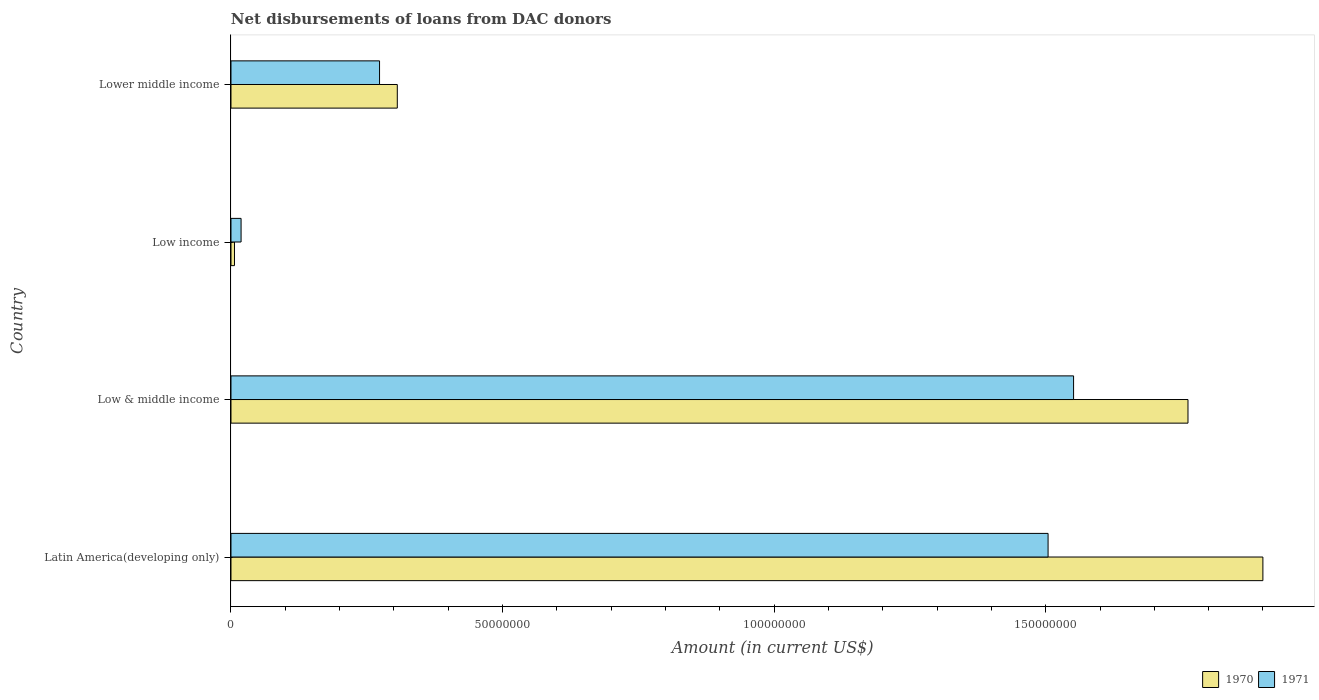How many different coloured bars are there?
Your answer should be compact. 2. Are the number of bars per tick equal to the number of legend labels?
Give a very brief answer. Yes. Are the number of bars on each tick of the Y-axis equal?
Provide a short and direct response. Yes. How many bars are there on the 4th tick from the top?
Ensure brevity in your answer.  2. How many bars are there on the 2nd tick from the bottom?
Your answer should be very brief. 2. What is the label of the 1st group of bars from the top?
Keep it short and to the point. Lower middle income. In how many cases, is the number of bars for a given country not equal to the number of legend labels?
Give a very brief answer. 0. What is the amount of loans disbursed in 1971 in Low & middle income?
Provide a short and direct response. 1.55e+08. Across all countries, what is the maximum amount of loans disbursed in 1971?
Ensure brevity in your answer.  1.55e+08. Across all countries, what is the minimum amount of loans disbursed in 1970?
Keep it short and to the point. 6.47e+05. In which country was the amount of loans disbursed in 1971 minimum?
Your answer should be compact. Low income. What is the total amount of loans disbursed in 1970 in the graph?
Offer a terse response. 3.97e+08. What is the difference between the amount of loans disbursed in 1970 in Latin America(developing only) and that in Lower middle income?
Your response must be concise. 1.59e+08. What is the difference between the amount of loans disbursed in 1971 in Low income and the amount of loans disbursed in 1970 in Latin America(developing only)?
Your response must be concise. -1.88e+08. What is the average amount of loans disbursed in 1971 per country?
Provide a short and direct response. 8.37e+07. What is the difference between the amount of loans disbursed in 1971 and amount of loans disbursed in 1970 in Latin America(developing only)?
Provide a succinct answer. -3.96e+07. What is the ratio of the amount of loans disbursed in 1971 in Low & middle income to that in Low income?
Offer a very short reply. 83.45. What is the difference between the highest and the second highest amount of loans disbursed in 1971?
Give a very brief answer. 4.69e+06. What is the difference between the highest and the lowest amount of loans disbursed in 1971?
Your answer should be very brief. 1.53e+08. In how many countries, is the amount of loans disbursed in 1971 greater than the average amount of loans disbursed in 1971 taken over all countries?
Provide a short and direct response. 2. Is the sum of the amount of loans disbursed in 1970 in Latin America(developing only) and Low income greater than the maximum amount of loans disbursed in 1971 across all countries?
Give a very brief answer. Yes. What does the 2nd bar from the bottom in Lower middle income represents?
Make the answer very short. 1971. How many bars are there?
Your response must be concise. 8. Are the values on the major ticks of X-axis written in scientific E-notation?
Your answer should be very brief. No. Does the graph contain any zero values?
Offer a terse response. No. How many legend labels are there?
Keep it short and to the point. 2. What is the title of the graph?
Provide a short and direct response. Net disbursements of loans from DAC donors. What is the Amount (in current US$) of 1970 in Latin America(developing only)?
Offer a very short reply. 1.90e+08. What is the Amount (in current US$) of 1971 in Latin America(developing only)?
Offer a terse response. 1.50e+08. What is the Amount (in current US$) in 1970 in Low & middle income?
Make the answer very short. 1.76e+08. What is the Amount (in current US$) in 1971 in Low & middle income?
Make the answer very short. 1.55e+08. What is the Amount (in current US$) of 1970 in Low income?
Your answer should be very brief. 6.47e+05. What is the Amount (in current US$) of 1971 in Low income?
Provide a short and direct response. 1.86e+06. What is the Amount (in current US$) in 1970 in Lower middle income?
Your answer should be very brief. 3.06e+07. What is the Amount (in current US$) of 1971 in Lower middle income?
Provide a short and direct response. 2.74e+07. Across all countries, what is the maximum Amount (in current US$) in 1970?
Provide a succinct answer. 1.90e+08. Across all countries, what is the maximum Amount (in current US$) of 1971?
Make the answer very short. 1.55e+08. Across all countries, what is the minimum Amount (in current US$) of 1970?
Keep it short and to the point. 6.47e+05. Across all countries, what is the minimum Amount (in current US$) of 1971?
Your response must be concise. 1.86e+06. What is the total Amount (in current US$) of 1970 in the graph?
Give a very brief answer. 3.97e+08. What is the total Amount (in current US$) in 1971 in the graph?
Your response must be concise. 3.35e+08. What is the difference between the Amount (in current US$) of 1970 in Latin America(developing only) and that in Low & middle income?
Your answer should be compact. 1.38e+07. What is the difference between the Amount (in current US$) in 1971 in Latin America(developing only) and that in Low & middle income?
Your answer should be compact. -4.69e+06. What is the difference between the Amount (in current US$) of 1970 in Latin America(developing only) and that in Low income?
Keep it short and to the point. 1.89e+08. What is the difference between the Amount (in current US$) in 1971 in Latin America(developing only) and that in Low income?
Make the answer very short. 1.49e+08. What is the difference between the Amount (in current US$) in 1970 in Latin America(developing only) and that in Lower middle income?
Keep it short and to the point. 1.59e+08. What is the difference between the Amount (in current US$) of 1971 in Latin America(developing only) and that in Lower middle income?
Offer a very short reply. 1.23e+08. What is the difference between the Amount (in current US$) in 1970 in Low & middle income and that in Low income?
Your response must be concise. 1.76e+08. What is the difference between the Amount (in current US$) of 1971 in Low & middle income and that in Low income?
Ensure brevity in your answer.  1.53e+08. What is the difference between the Amount (in current US$) of 1970 in Low & middle income and that in Lower middle income?
Give a very brief answer. 1.46e+08. What is the difference between the Amount (in current US$) in 1971 in Low & middle income and that in Lower middle income?
Your answer should be very brief. 1.28e+08. What is the difference between the Amount (in current US$) in 1970 in Low income and that in Lower middle income?
Make the answer very short. -3.00e+07. What is the difference between the Amount (in current US$) in 1971 in Low income and that in Lower middle income?
Keep it short and to the point. -2.55e+07. What is the difference between the Amount (in current US$) of 1970 in Latin America(developing only) and the Amount (in current US$) of 1971 in Low & middle income?
Keep it short and to the point. 3.49e+07. What is the difference between the Amount (in current US$) in 1970 in Latin America(developing only) and the Amount (in current US$) in 1971 in Low income?
Keep it short and to the point. 1.88e+08. What is the difference between the Amount (in current US$) of 1970 in Latin America(developing only) and the Amount (in current US$) of 1971 in Lower middle income?
Give a very brief answer. 1.63e+08. What is the difference between the Amount (in current US$) in 1970 in Low & middle income and the Amount (in current US$) in 1971 in Low income?
Ensure brevity in your answer.  1.74e+08. What is the difference between the Amount (in current US$) of 1970 in Low & middle income and the Amount (in current US$) of 1971 in Lower middle income?
Your answer should be compact. 1.49e+08. What is the difference between the Amount (in current US$) in 1970 in Low income and the Amount (in current US$) in 1971 in Lower middle income?
Ensure brevity in your answer.  -2.67e+07. What is the average Amount (in current US$) in 1970 per country?
Offer a very short reply. 9.94e+07. What is the average Amount (in current US$) in 1971 per country?
Give a very brief answer. 8.37e+07. What is the difference between the Amount (in current US$) of 1970 and Amount (in current US$) of 1971 in Latin America(developing only)?
Offer a terse response. 3.96e+07. What is the difference between the Amount (in current US$) in 1970 and Amount (in current US$) in 1971 in Low & middle income?
Provide a short and direct response. 2.11e+07. What is the difference between the Amount (in current US$) in 1970 and Amount (in current US$) in 1971 in Low income?
Give a very brief answer. -1.21e+06. What is the difference between the Amount (in current US$) in 1970 and Amount (in current US$) in 1971 in Lower middle income?
Provide a short and direct response. 3.27e+06. What is the ratio of the Amount (in current US$) of 1970 in Latin America(developing only) to that in Low & middle income?
Your answer should be compact. 1.08. What is the ratio of the Amount (in current US$) of 1971 in Latin America(developing only) to that in Low & middle income?
Keep it short and to the point. 0.97. What is the ratio of the Amount (in current US$) of 1970 in Latin America(developing only) to that in Low income?
Give a very brief answer. 293.65. What is the ratio of the Amount (in current US$) in 1971 in Latin America(developing only) to that in Low income?
Provide a short and direct response. 80.93. What is the ratio of the Amount (in current US$) in 1970 in Latin America(developing only) to that in Lower middle income?
Your answer should be compact. 6.2. What is the ratio of the Amount (in current US$) in 1971 in Latin America(developing only) to that in Lower middle income?
Make the answer very short. 5.5. What is the ratio of the Amount (in current US$) in 1970 in Low & middle income to that in Low income?
Make the answer very short. 272.33. What is the ratio of the Amount (in current US$) in 1971 in Low & middle income to that in Low income?
Provide a short and direct response. 83.45. What is the ratio of the Amount (in current US$) in 1970 in Low & middle income to that in Lower middle income?
Your answer should be very brief. 5.75. What is the ratio of the Amount (in current US$) in 1971 in Low & middle income to that in Lower middle income?
Your answer should be compact. 5.67. What is the ratio of the Amount (in current US$) in 1970 in Low income to that in Lower middle income?
Keep it short and to the point. 0.02. What is the ratio of the Amount (in current US$) in 1971 in Low income to that in Lower middle income?
Offer a terse response. 0.07. What is the difference between the highest and the second highest Amount (in current US$) in 1970?
Provide a succinct answer. 1.38e+07. What is the difference between the highest and the second highest Amount (in current US$) in 1971?
Your response must be concise. 4.69e+06. What is the difference between the highest and the lowest Amount (in current US$) in 1970?
Offer a very short reply. 1.89e+08. What is the difference between the highest and the lowest Amount (in current US$) in 1971?
Your answer should be compact. 1.53e+08. 